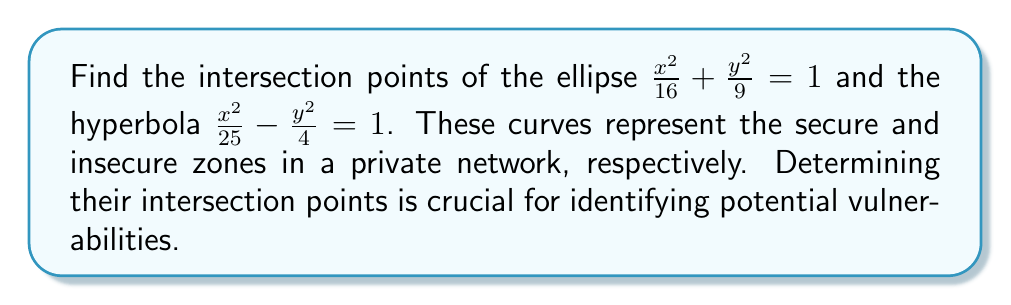Can you answer this question? 1) First, let's set up a system of equations:

   $$\frac{x^2}{16} + \frac{y^2}{9} = 1 \quad \text{(Equation 1)}$$
   $$\frac{x^2}{25} - \frac{y^2}{4} = 1 \quad \text{(Equation 2)}$$

2) Multiply Equation 1 by 144 and Equation 2 by 100:

   $$9x^2 + 16y^2 = 144 \quad \text{(Equation 3)}$$
   $$4x^2 - 25y^2 = 100 \quad \text{(Equation 4)}$$

3) Subtract Equation 4 from Equation 3:

   $$5x^2 + 41y^2 = 44$$

4) Divide by 5:

   $$x^2 + \frac{41}{5}y^2 = \frac{44}{5}$$

5) Substitute this expression for $x^2$ into Equation 2:

   $$\frac{1}{25}(\frac{44}{5} - \frac{41}{5}y^2) - \frac{y^2}{4} = 1$$

6) Simplify:

   $$\frac{44}{125} - \frac{41}{125}y^2 - \frac{y^2}{4} = 1$$
   $$44 - 41y^2 - 31.25y^2 = 125$$
   $$-72.25y^2 = 81$$
   $$y^2 = \frac{81}{72.25} = (\frac{9}{8.5})^2$$

7) Solve for y:

   $$y = \pm \frac{9}{8.5} = \pm \frac{18}{17}$$

8) Substitute these y-values back into Equation 2 to find x:

   $$\frac{x^2}{25} - \frac{(\frac{18}{17})^2}{4} = 1$$
   $$\frac{x^2}{25} = 1 + \frac{324}{1156} = \frac{1480}{1156}$$
   $$x^2 = \frac{37000}{1156} = (\frac{120}{34})^2$$
   $$x = \pm \frac{120}{34}$$

9) Therefore, the intersection points are:

   $$(\frac{120}{34}, \frac{18}{17}) \text{ and } (-\frac{120}{34}, -\frac{18}{17})$$
Answer: $(\frac{120}{34}, \frac{18}{17})$ and $(-\frac{120}{34}, -\frac{18}{17})$ 